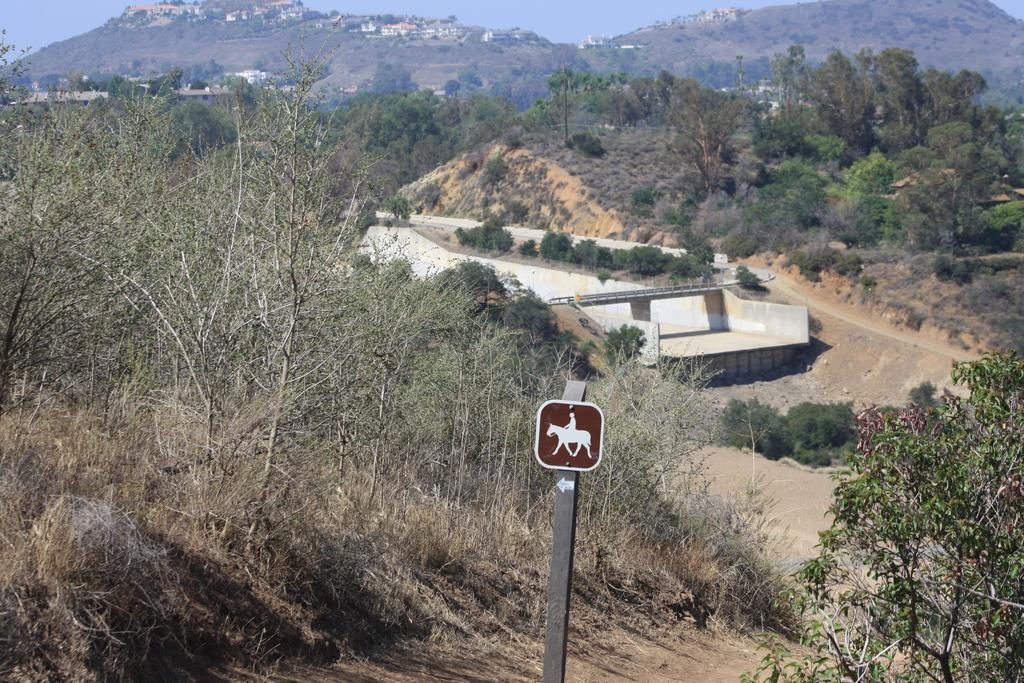What type of vegetation can be seen in the image? There are trees, plants, and grass in the image. What structures are present in the image? There is a pole, a bridge, and buildings in the image. What type of terrain is visible in the image? There are hills in the image. What is visible in the background of the image? The sky is visible in the image. How many taxes are being paid by the trees in the image? There are no taxes mentioned or implied in the image, as it features trees, a pole, a road, a bridge, plants, grass, hills, buildings, and the sky. What type of rock is being used to build the bridge in the image? There is no information about the materials used to build the bridge in the image. 